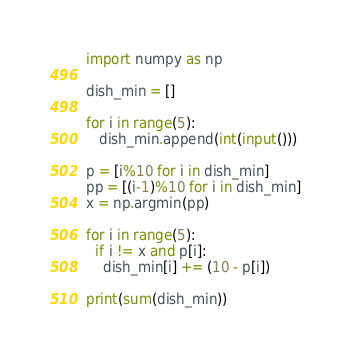<code> <loc_0><loc_0><loc_500><loc_500><_Python_>import numpy as np

dish_min = []
 
for i in range(5):
   dish_min.append(int(input()))
    
p = [i%10 for i in dish_min]
pp = [(i-1)%10 for i in dish_min]
x = np.argmin(pp)

for i in range(5):
  if i != x and p[i]:
  	dish_min[i] += (10 - p[i])

print(sum(dish_min))</code> 